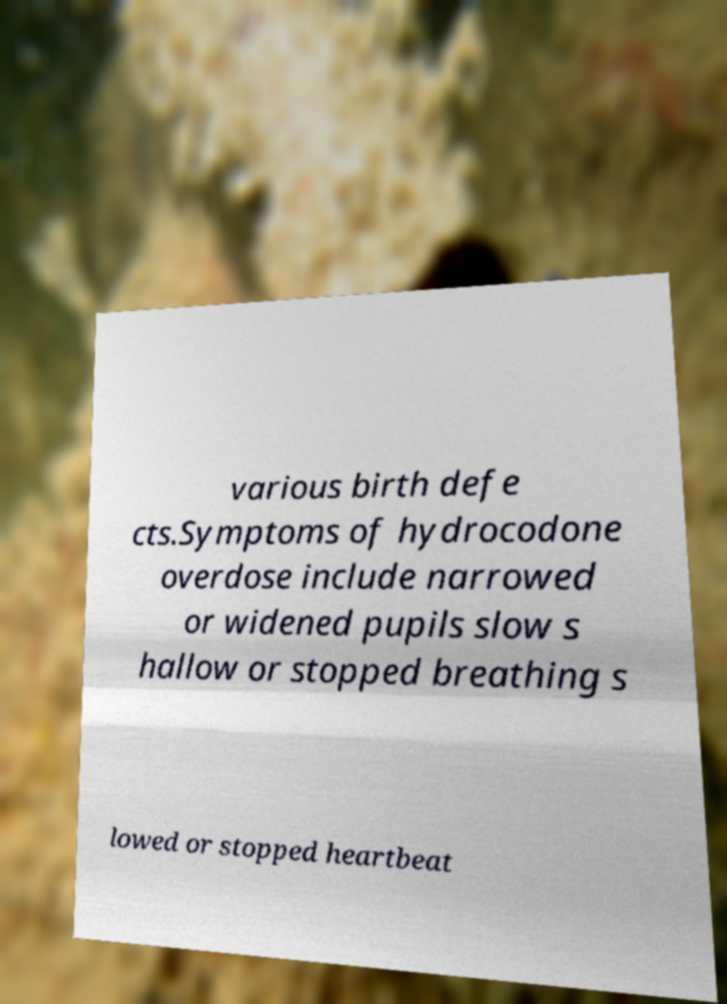Please identify and transcribe the text found in this image. various birth defe cts.Symptoms of hydrocodone overdose include narrowed or widened pupils slow s hallow or stopped breathing s lowed or stopped heartbeat 